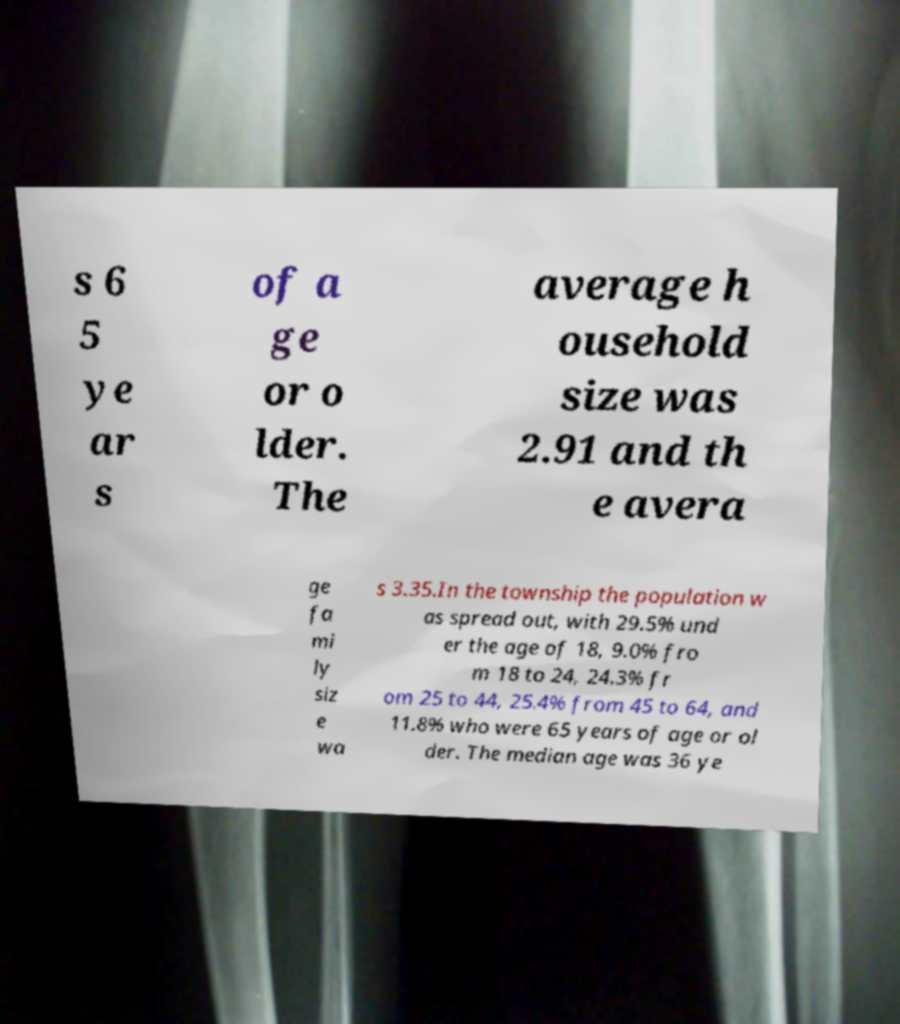What messages or text are displayed in this image? I need them in a readable, typed format. s 6 5 ye ar s of a ge or o lder. The average h ousehold size was 2.91 and th e avera ge fa mi ly siz e wa s 3.35.In the township the population w as spread out, with 29.5% und er the age of 18, 9.0% fro m 18 to 24, 24.3% fr om 25 to 44, 25.4% from 45 to 64, and 11.8% who were 65 years of age or ol der. The median age was 36 ye 